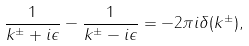<formula> <loc_0><loc_0><loc_500><loc_500>\frac { 1 } { k ^ { \pm } + i \epsilon } - \frac { 1 } { k ^ { \pm } - i \epsilon } = - 2 \pi i \delta ( k ^ { \pm } ) ,</formula> 